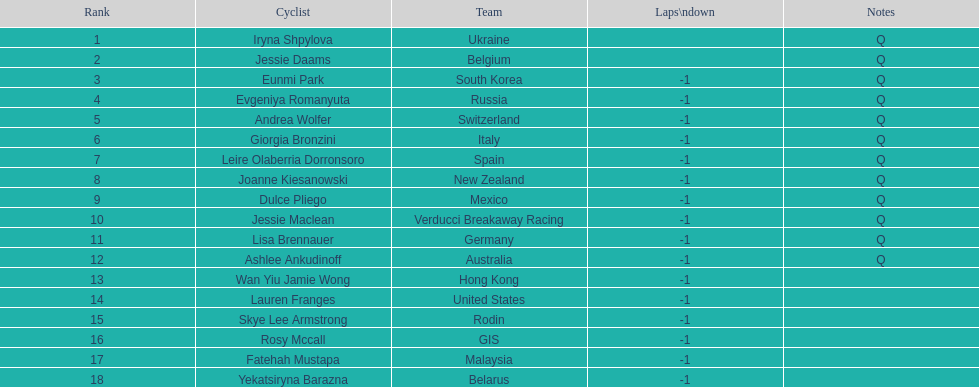What is belgium's numerical ranking? 2. 